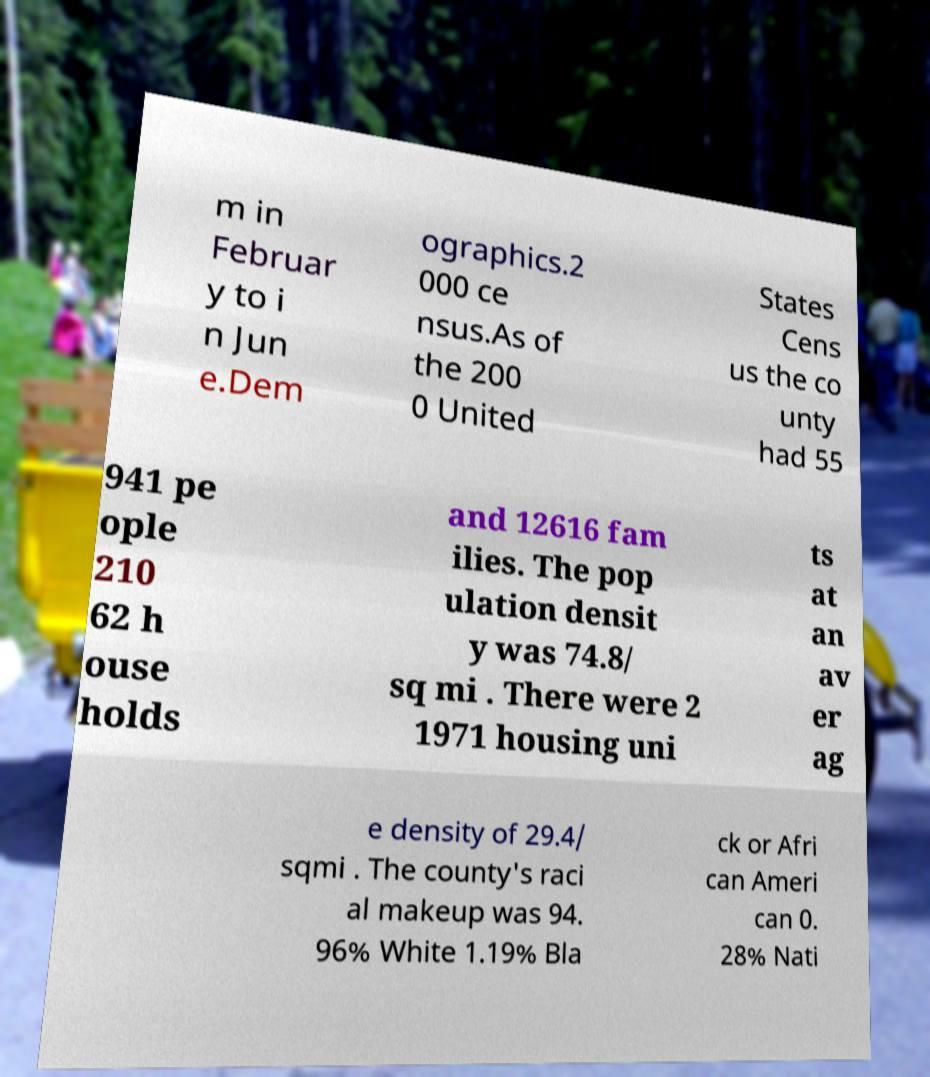Can you read and provide the text displayed in the image?This photo seems to have some interesting text. Can you extract and type it out for me? m in Februar y to i n Jun e.Dem ographics.2 000 ce nsus.As of the 200 0 United States Cens us the co unty had 55 941 pe ople 210 62 h ouse holds and 12616 fam ilies. The pop ulation densit y was 74.8/ sq mi . There were 2 1971 housing uni ts at an av er ag e density of 29.4/ sqmi . The county's raci al makeup was 94. 96% White 1.19% Bla ck or Afri can Ameri can 0. 28% Nati 